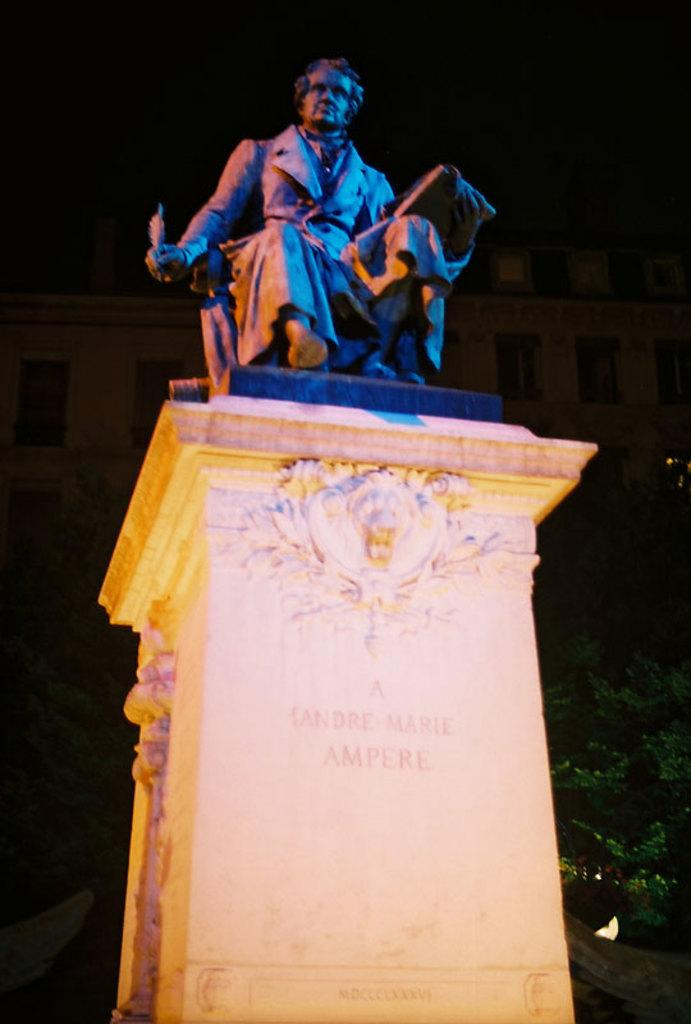What is the main subject of the image? The main subject of the image is a statue. Can you describe the statue in the image? The statue is of a person. Where is the statue located in the image? The statue is placed on a tall wall. What type of plants can be seen growing around the statue in the image? There is no mention of plants in the image, so we cannot determine if any are present. 